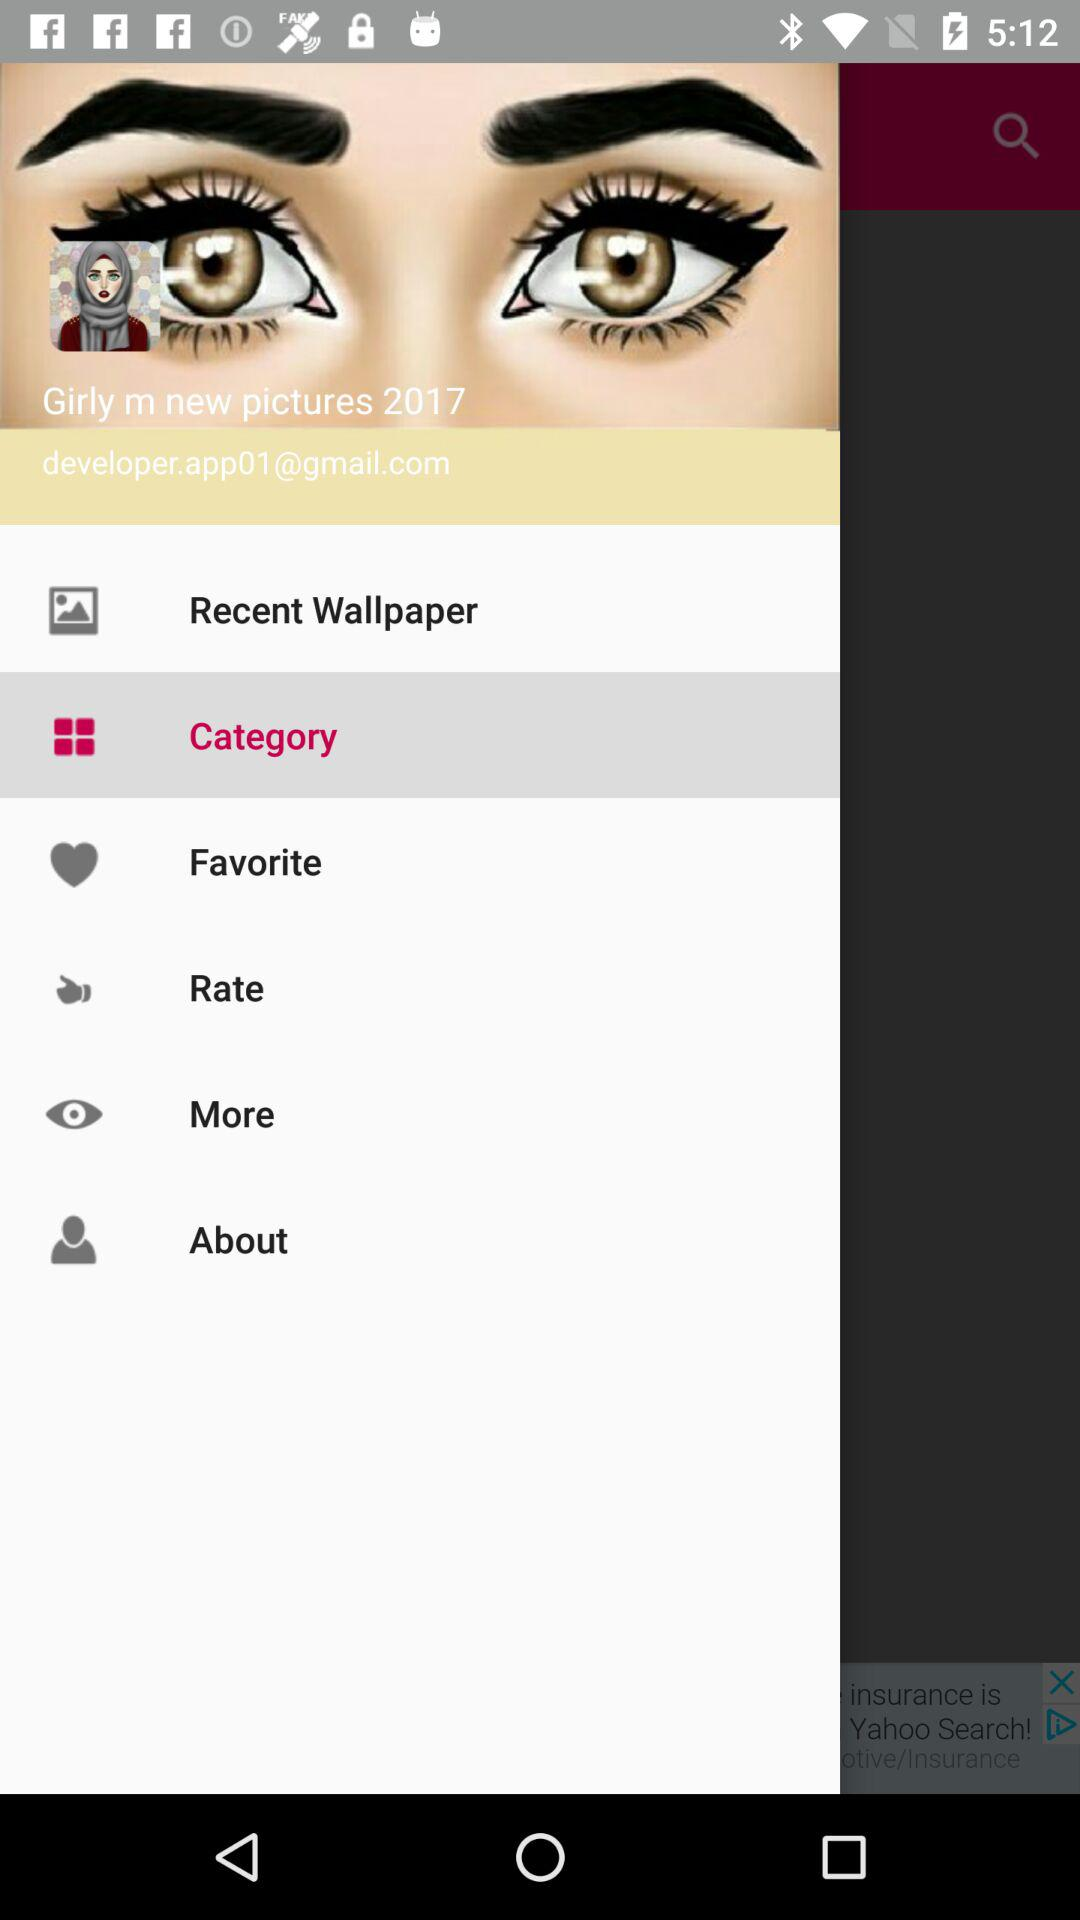What is the email address? The email address is developer.app01@gmail.com. 